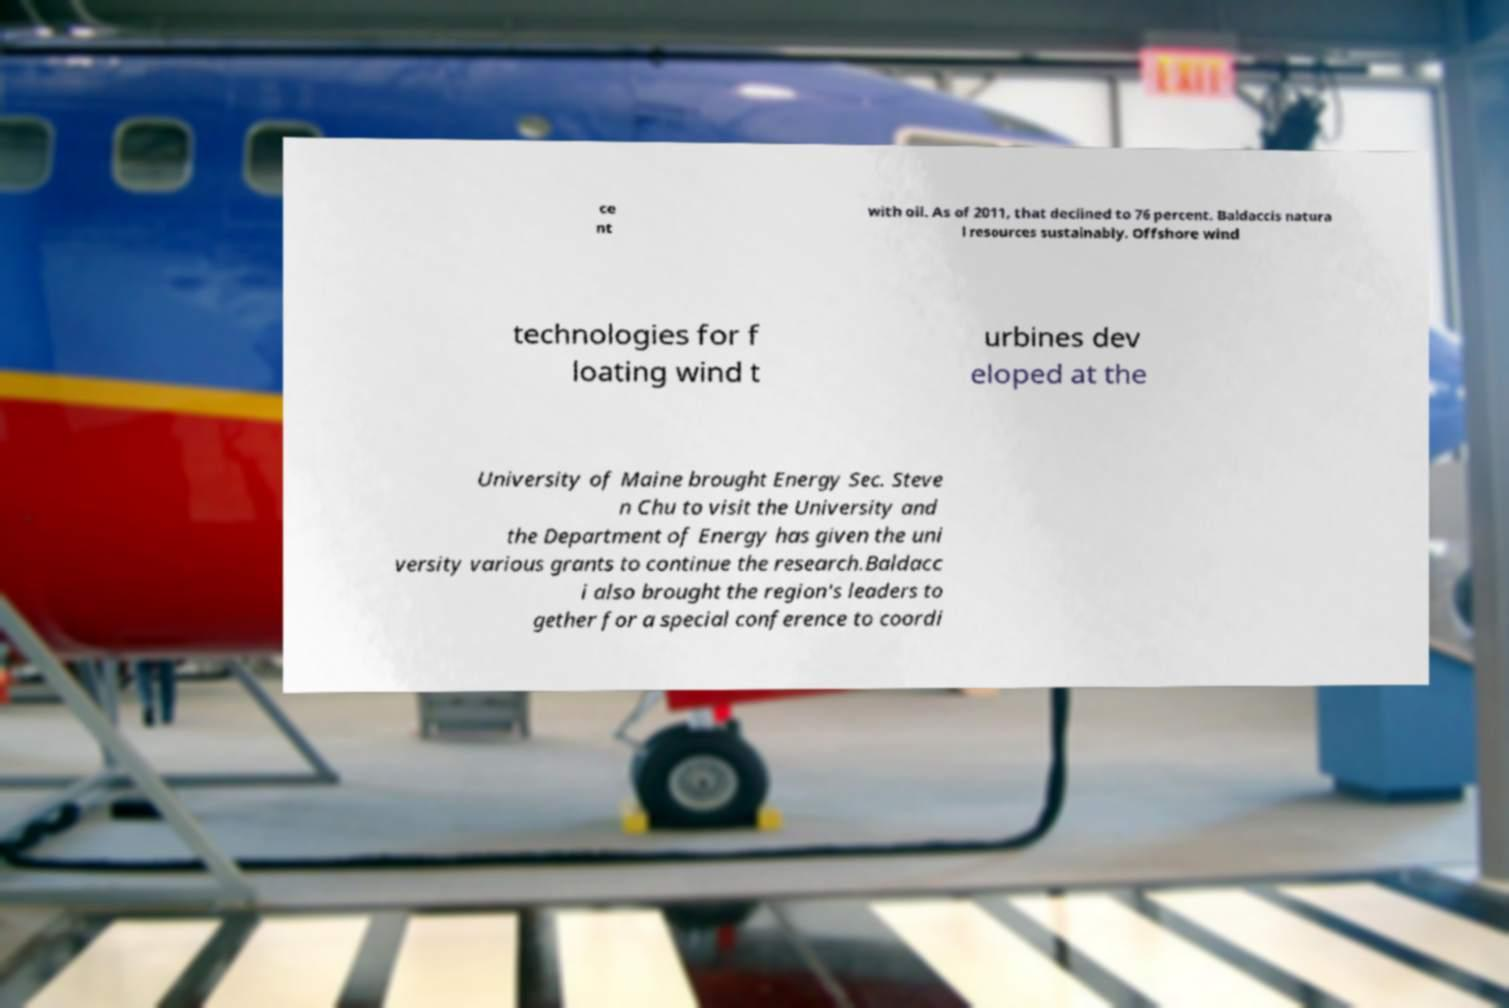Could you extract and type out the text from this image? ce nt with oil. As of 2011, that declined to 76 percent. Baldaccis natura l resources sustainably. Offshore wind technologies for f loating wind t urbines dev eloped at the University of Maine brought Energy Sec. Steve n Chu to visit the University and the Department of Energy has given the uni versity various grants to continue the research.Baldacc i also brought the region's leaders to gether for a special conference to coordi 